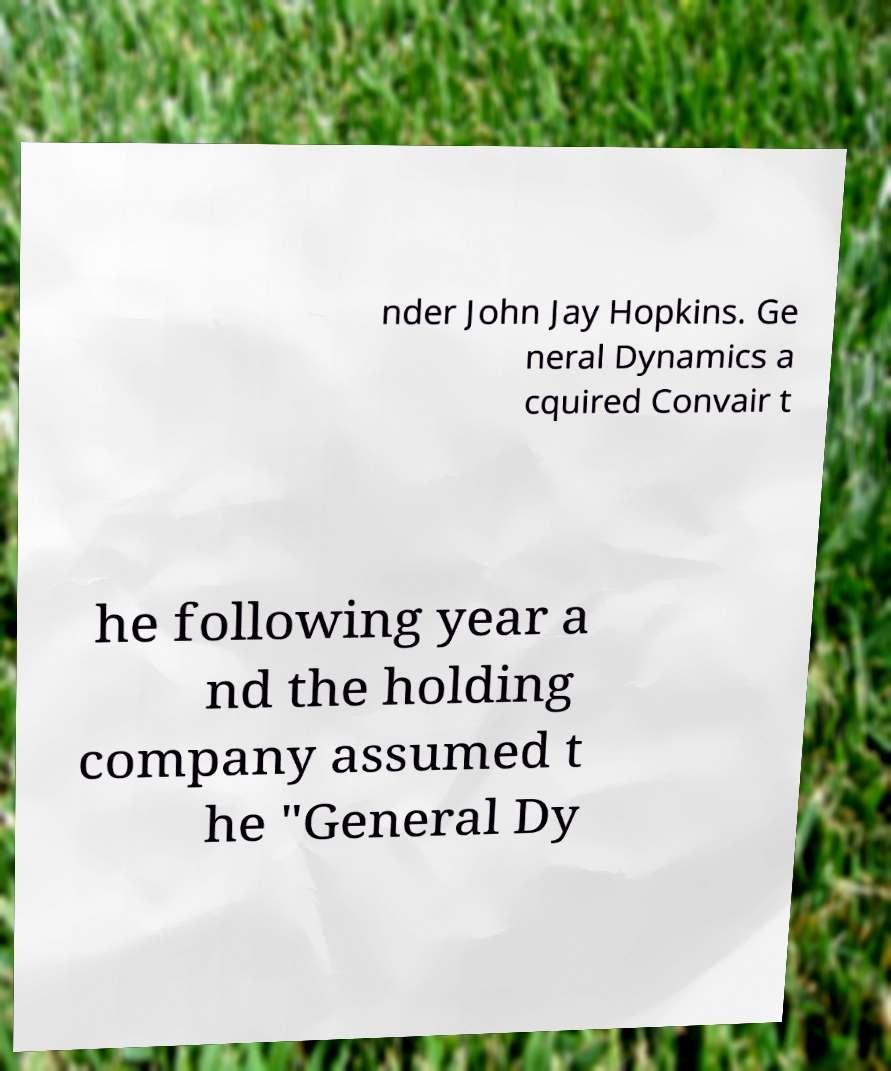There's text embedded in this image that I need extracted. Can you transcribe it verbatim? nder John Jay Hopkins. Ge neral Dynamics a cquired Convair t he following year a nd the holding company assumed t he "General Dy 